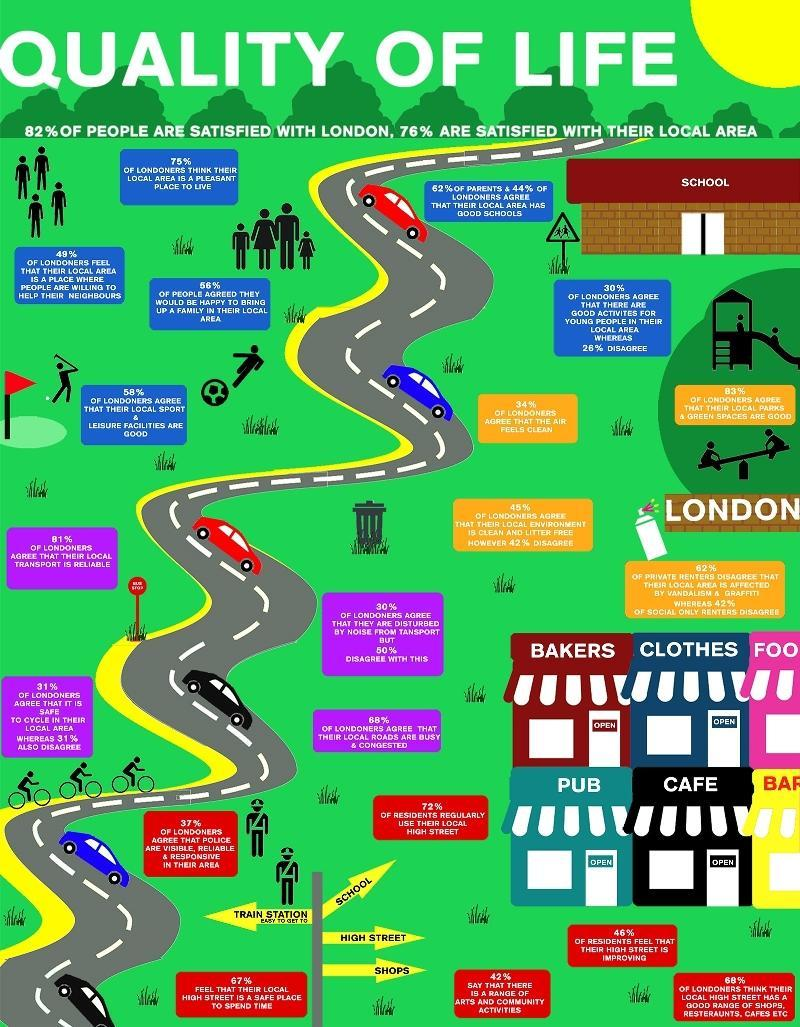How many cars are in this infographic?
Answer the question with a short phrase. 6 How many cycles are in this infographic? 3 What percentage of Londoners disagree that police are visible in their area? 63% What percentage of residents didn't use their local high street regularly? 28% 